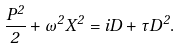Convert formula to latex. <formula><loc_0><loc_0><loc_500><loc_500>\frac { P ^ { 2 } } { 2 } + \omega ^ { 2 } X ^ { 2 } = i D + \tau D ^ { 2 } .</formula> 